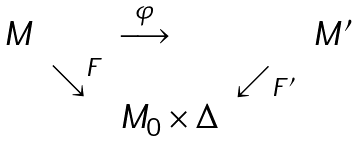<formula> <loc_0><loc_0><loc_500><loc_500>\begin{array} { l l l l l } M & & \overset { \varphi } { \longrightarrow } & & M ^ { \prime } \\ & \searrow ^ { F } & & \swarrow _ { F ^ { \prime } } & \\ & & M _ { 0 } \times \Delta & & \end{array}</formula> 